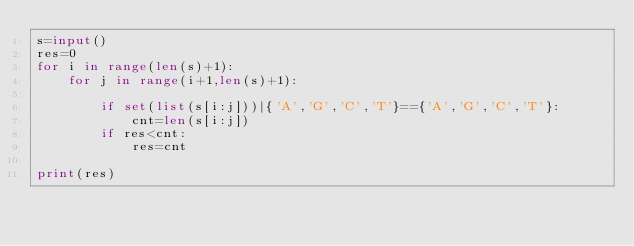<code> <loc_0><loc_0><loc_500><loc_500><_Python_>s=input()
res=0
for i in range(len(s)+1):
    for j in range(i+1,len(s)+1):
       
        if set(list(s[i:j]))|{'A','G','C','T'}=={'A','G','C','T'}:
            cnt=len(s[i:j])
        if res<cnt:
            res=cnt

print(res)</code> 